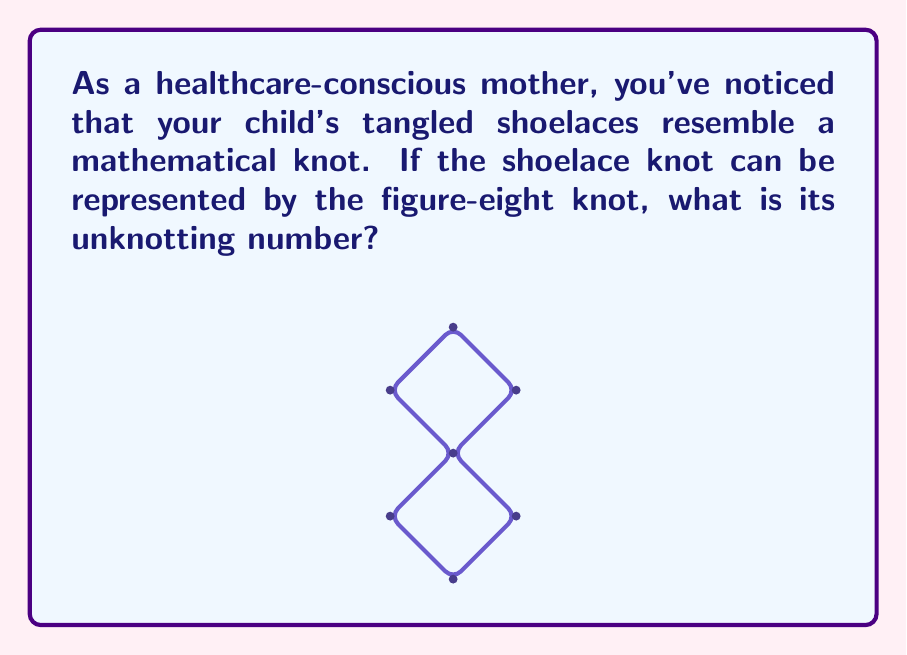Provide a solution to this math problem. To determine the unknotting number of the figure-eight knot, we'll follow these steps:

1. Understand the concept: The unknotting number is the minimum number of crossing changes required to transform a knot into the unknot (trivial knot).

2. Analyze the figure-eight knot:
   - The figure-eight knot has 4 crossings.
   - It is a prime knot, meaning it cannot be decomposed into simpler knots.

3. Consider possible unknotting sequences:
   - Changing any single crossing does not unknot the figure-eight knot.
   - We need to change at least two crossings to unknot it.

4. Prove the lower bound:
   - The figure-eight knot has a signature of 0.
   - The signature of a knot changes by at most 2 with each crossing change.
   - Therefore, the unknotting number must be at least 1.

5. Prove the upper bound:
   - We can actually unknot the figure-eight knot with just one crossing change.
   - Change one of the crossings to its opposite, and the knot becomes equivalent to the trivial knot.

6. Conclusion:
   The unknotting number of the figure-eight knot is 1, as we can unknot it with a single crossing change, and this is the minimum possible.

This result is mathematically represented as:

$$u(4_1) = 1$$

Where $4_1$ is the standard notation for the figure-eight knot in knot theory.
Answer: 1 